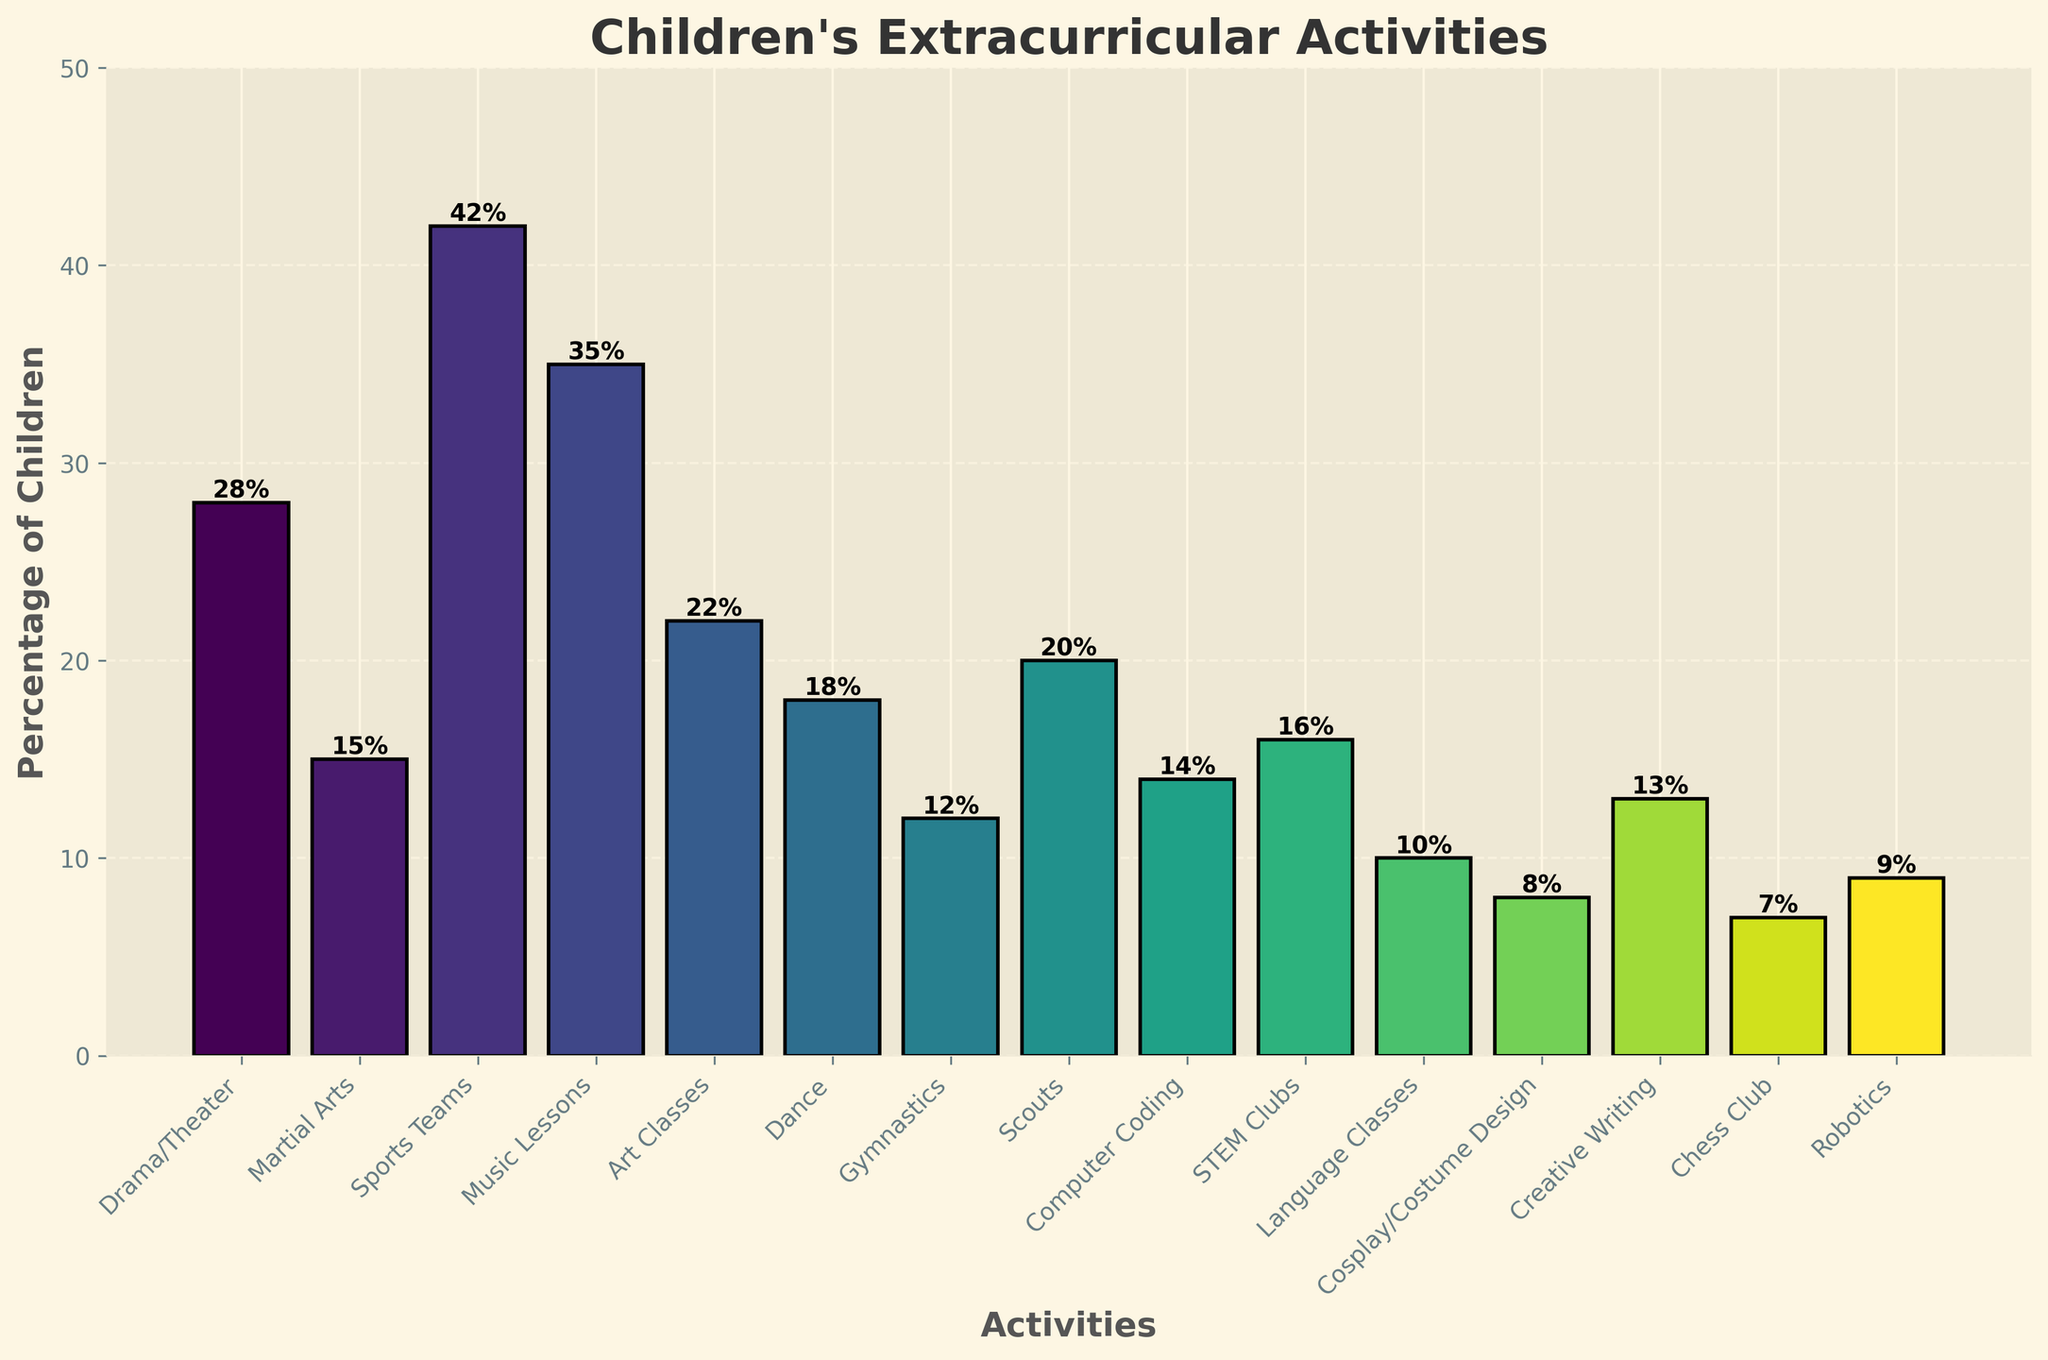What percentage of children participates in Drama/Theater compared to Martial Arts? To answer this, find the percentage of children participating in Drama/Theater and Martial Arts from the chart. Drama/Theater is 28%, and Martial Arts is 15%. Compare these two percentages.
Answer: Drama/Theater: 28%, Martial Arts: 15% Which extracurricular activity has the highest participation rate? Look for the tallest bar in the bar chart, which represents the activity with the highest participation percentage.
Answer: Sports Teams: 42% How many more children participate in Music Lessons than in Creative Writing? Find the percentages for Music Lessons and Creative Writing. Music Lessons is 35%, and Creative Writing is 13%. Subtract the smaller percentage from the larger one: 35% - 13% = 22%.
Answer: 22% Which activity has a lower participation percentage, Language Classes or Robotics? Compare the heights of the bars for Language Classes and Robotics. Language Classes has 10%, and Robotics has 9%.
Answer: Robotics: 9% What is the average participation rate for the activities listed in the chart? First, sum all the percentages: 
28 + 15 + 42 + 35 + 22 + 18 + 12 + 20 + 14 + 16 + 10 + 8 + 13 + 7 + 9 = 269. 
Then, divide by the number of activities: 269 / 15 = 17.93.
Answer: 17.93% Which activity has the most similar participation rate to STEM Clubs? Identify the percentage for STEM Clubs (16%) and find the bar with the closest percentage to this value. Computer Coding has 14%, which is the closest to 16%.
Answer: Computer Coding: 14% Which two activities together make up for the highest combined participation rate? Identify the two tallest bars in the chart. Sports Teams (42%) and Music Lessons (35%). Their combined rate is 42% + 35% = 77%.
Answer: Sports Teams and Music Lessons: 77% Is the participation in Chess Club lower than in Scouts? Compare the percentages for Chess Club and Scouts. Chess Club has 7%, and Scouts have 20%. Since 7% is less than 20%, the answer is yes.
Answer: Yes How much higher is the participation rate in Art Classes compared to Dance? Find the percentages for Art Classes and Dance. Art Classes is 22%, and Dance is 18%. Subtract the smaller percentage from the larger one: 22% - 18% = 4%.
Answer: 4% Which three activities combined have a participation rate closest to 50%? List potential combinations and calculate their sums. For instance, Drama/Theater (28%) + STEM Clubs (16%) + Creative Writing (13%) = 28% + 16% + 13% = 57%. Recalculate for each combination until you find the closest to 50%. Another option is Language Classes (10%) + Art Classes (22%) + Martial Arts (15%) = 10% + 22% + 15% = 47%.
Answer: Language Classes, Art Classes, and Martial Arts: 47% 